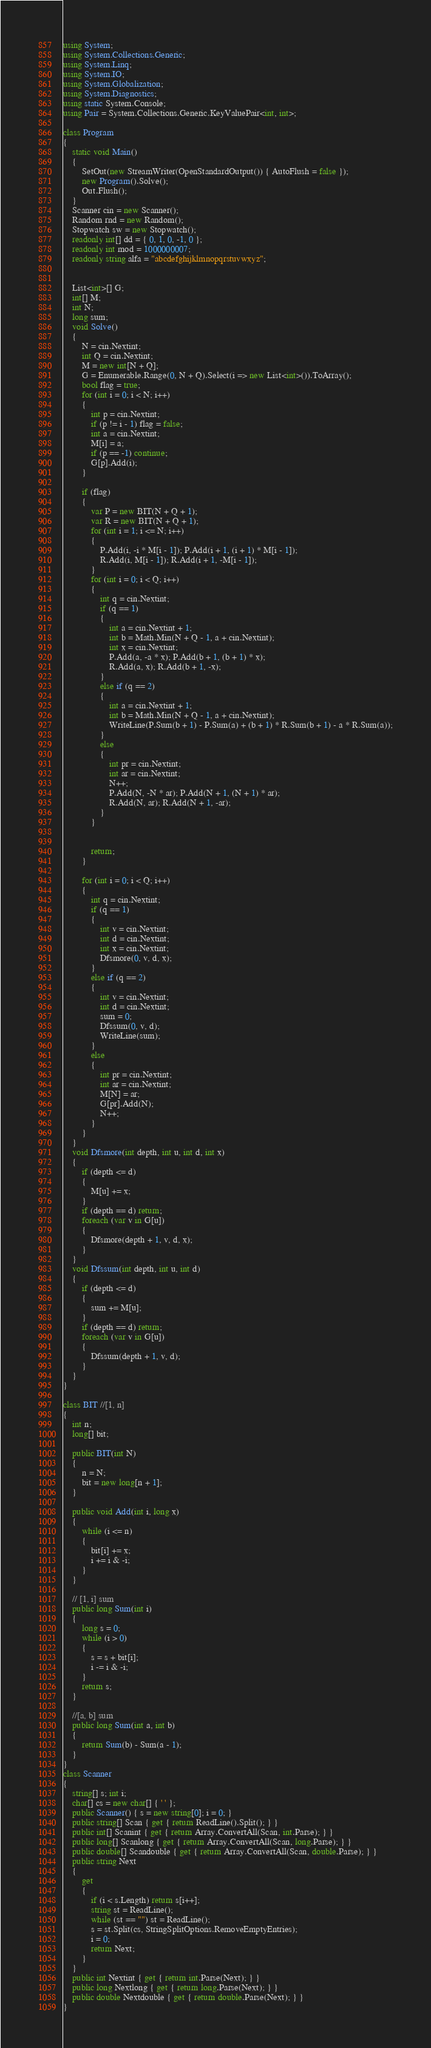<code> <loc_0><loc_0><loc_500><loc_500><_C#_>using System;
using System.Collections.Generic;
using System.Linq;
using System.IO;
using System.Globalization;
using System.Diagnostics;
using static System.Console;
using Pair = System.Collections.Generic.KeyValuePair<int, int>;

class Program
{
    static void Main()
    {
        SetOut(new StreamWriter(OpenStandardOutput()) { AutoFlush = false });
        new Program().Solve();
        Out.Flush();
    }
    Scanner cin = new Scanner();
    Random rnd = new Random();
    Stopwatch sw = new Stopwatch();
    readonly int[] dd = { 0, 1, 0, -1, 0 };
    readonly int mod = 1000000007;
    readonly string alfa = "abcdefghijklmnopqrstuvwxyz";


    List<int>[] G;
    int[] M;
    int N;
    long sum;
    void Solve()
    {
        N = cin.Nextint;
        int Q = cin.Nextint;
        M = new int[N + Q];
        G = Enumerable.Range(0, N + Q).Select(i => new List<int>()).ToArray();
        bool flag = true;
        for (int i = 0; i < N; i++)
        {
            int p = cin.Nextint;
            if (p != i - 1) flag = false;
            int a = cin.Nextint;
            M[i] = a;
            if (p == -1) continue;
            G[p].Add(i);
        }

        if (flag)
        {
            var P = new BIT(N + Q + 1);
            var R = new BIT(N + Q + 1);
            for (int i = 1; i <= N; i++)
            {
                P.Add(i, -i * M[i - 1]); P.Add(i + 1, (i + 1) * M[i - 1]);
                R.Add(i, M[i - 1]); R.Add(i + 1, -M[i - 1]);
            }
            for (int i = 0; i < Q; i++)
            {
                int q = cin.Nextint;
                if (q == 1)
                {
                    int a = cin.Nextint + 1;
                    int b = Math.Min(N + Q - 1, a + cin.Nextint);
                    int x = cin.Nextint;
                    P.Add(a, -a * x); P.Add(b + 1, (b + 1) * x);
                    R.Add(a, x); R.Add(b + 1, -x);
                }
                else if (q == 2)
                {
                    int a = cin.Nextint + 1;
                    int b = Math.Min(N + Q - 1, a + cin.Nextint);
                    WriteLine(P.Sum(b + 1) - P.Sum(a) + (b + 1) * R.Sum(b + 1) - a * R.Sum(a));
                }
                else
                {
                    int pr = cin.Nextint;
                    int ar = cin.Nextint;
                    N++;
                    P.Add(N, -N * ar); P.Add(N + 1, (N + 1) * ar);
                    R.Add(N, ar); R.Add(N + 1, -ar);
                }
            }


            return;
        }

        for (int i = 0; i < Q; i++)
        {
            int q = cin.Nextint;
            if (q == 1)
            {
                int v = cin.Nextint;
                int d = cin.Nextint;
                int x = cin.Nextint;
                Dfsmore(0, v, d, x);
            }
            else if (q == 2)
            {
                int v = cin.Nextint;
                int d = cin.Nextint;
                sum = 0;
                Dfssum(0, v, d);
                WriteLine(sum);
            }
            else
            {
                int pr = cin.Nextint;
                int ar = cin.Nextint;
                M[N] = ar;
                G[pr].Add(N);
                N++;
            }
        }
    }
    void Dfsmore(int depth, int u, int d, int x)
    {
        if (depth <= d)
        {
            M[u] += x;
        }
        if (depth == d) return;
        foreach (var v in G[u])
        {
            Dfsmore(depth + 1, v, d, x);
        }
    }
    void Dfssum(int depth, int u, int d)
    {
        if (depth <= d)
        {
            sum += M[u];
        }
        if (depth == d) return;
        foreach (var v in G[u])
        {
            Dfssum(depth + 1, v, d);
        }
    }
}

class BIT //[1, n]
{
    int n;
    long[] bit;

    public BIT(int N)
    {
        n = N;
        bit = new long[n + 1];
    }

    public void Add(int i, long x)
    {
        while (i <= n)
        {
            bit[i] += x;
            i += i & -i;
        }
    }

    // [1, i] sum
    public long Sum(int i)
    {
        long s = 0;
        while (i > 0)
        {
            s = s + bit[i];
            i -= i & -i;
        }
        return s;
    }

    //[a, b] sum
    public long Sum(int a, int b)
    {
        return Sum(b) - Sum(a - 1);
    }
}
class Scanner
{
    string[] s; int i;
    char[] cs = new char[] { ' ' };
    public Scanner() { s = new string[0]; i = 0; }
    public string[] Scan { get { return ReadLine().Split(); } }
    public int[] Scanint { get { return Array.ConvertAll(Scan, int.Parse); } }
    public long[] Scanlong { get { return Array.ConvertAll(Scan, long.Parse); } }
    public double[] Scandouble { get { return Array.ConvertAll(Scan, double.Parse); } }
    public string Next
    {
        get
        {
            if (i < s.Length) return s[i++];
            string st = ReadLine();
            while (st == "") st = ReadLine();
            s = st.Split(cs, StringSplitOptions.RemoveEmptyEntries);
            i = 0;
            return Next;
        }
    }
    public int Nextint { get { return int.Parse(Next); } }
    public long Nextlong { get { return long.Parse(Next); } }
    public double Nextdouble { get { return double.Parse(Next); } }
}</code> 